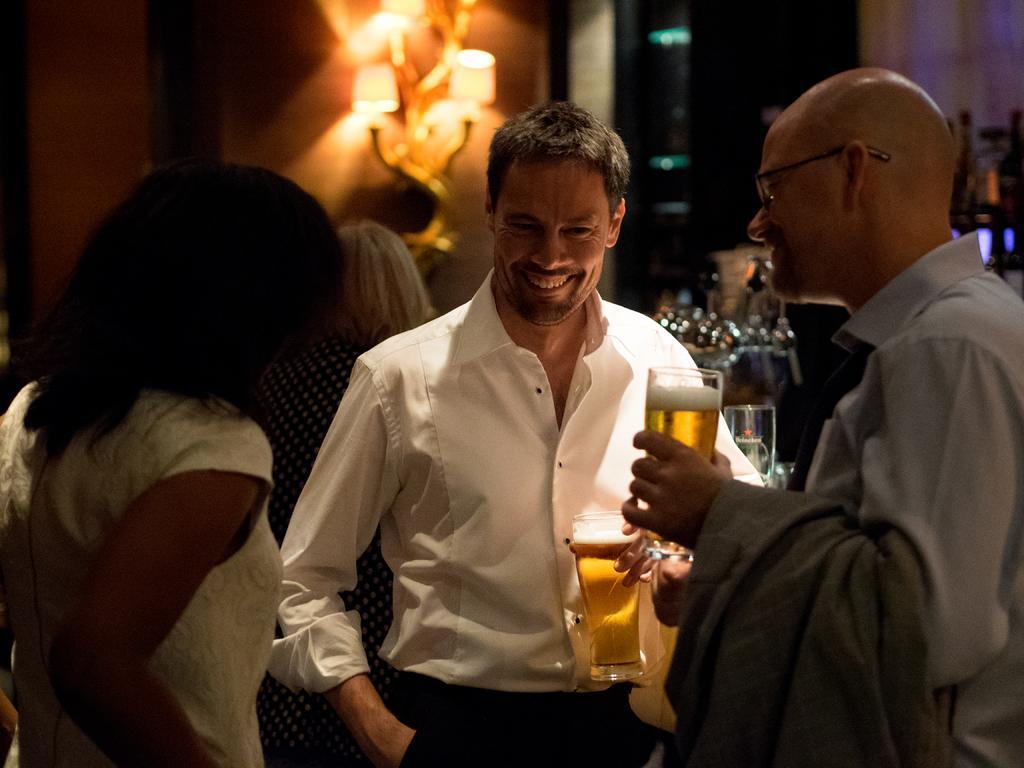Can you describe this image briefly? In this picture there is a man who is wearing a white shirt and trouser. Beside him we can see a woman who is wearing white dress. On the right there is a bald man who is wearing shirt, spectacle and holding a wine glasses and jacket. In the background we can see a woman who is standing near to the wall. On the wall we can see the lamps. 